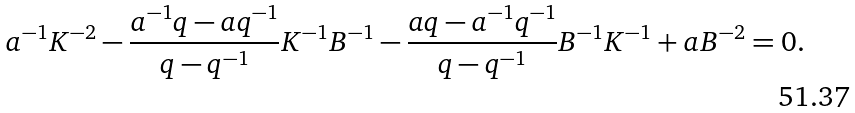<formula> <loc_0><loc_0><loc_500><loc_500>& a ^ { - 1 } K ^ { - 2 } - \frac { a ^ { - 1 } q - a q ^ { - 1 } } { q - q ^ { - 1 } } K ^ { - 1 } B ^ { - 1 } - \frac { a q - a ^ { - 1 } q ^ { - 1 } } { q - q ^ { - 1 } } B ^ { - 1 } K ^ { - 1 } + a B ^ { - 2 } = 0 .</formula> 